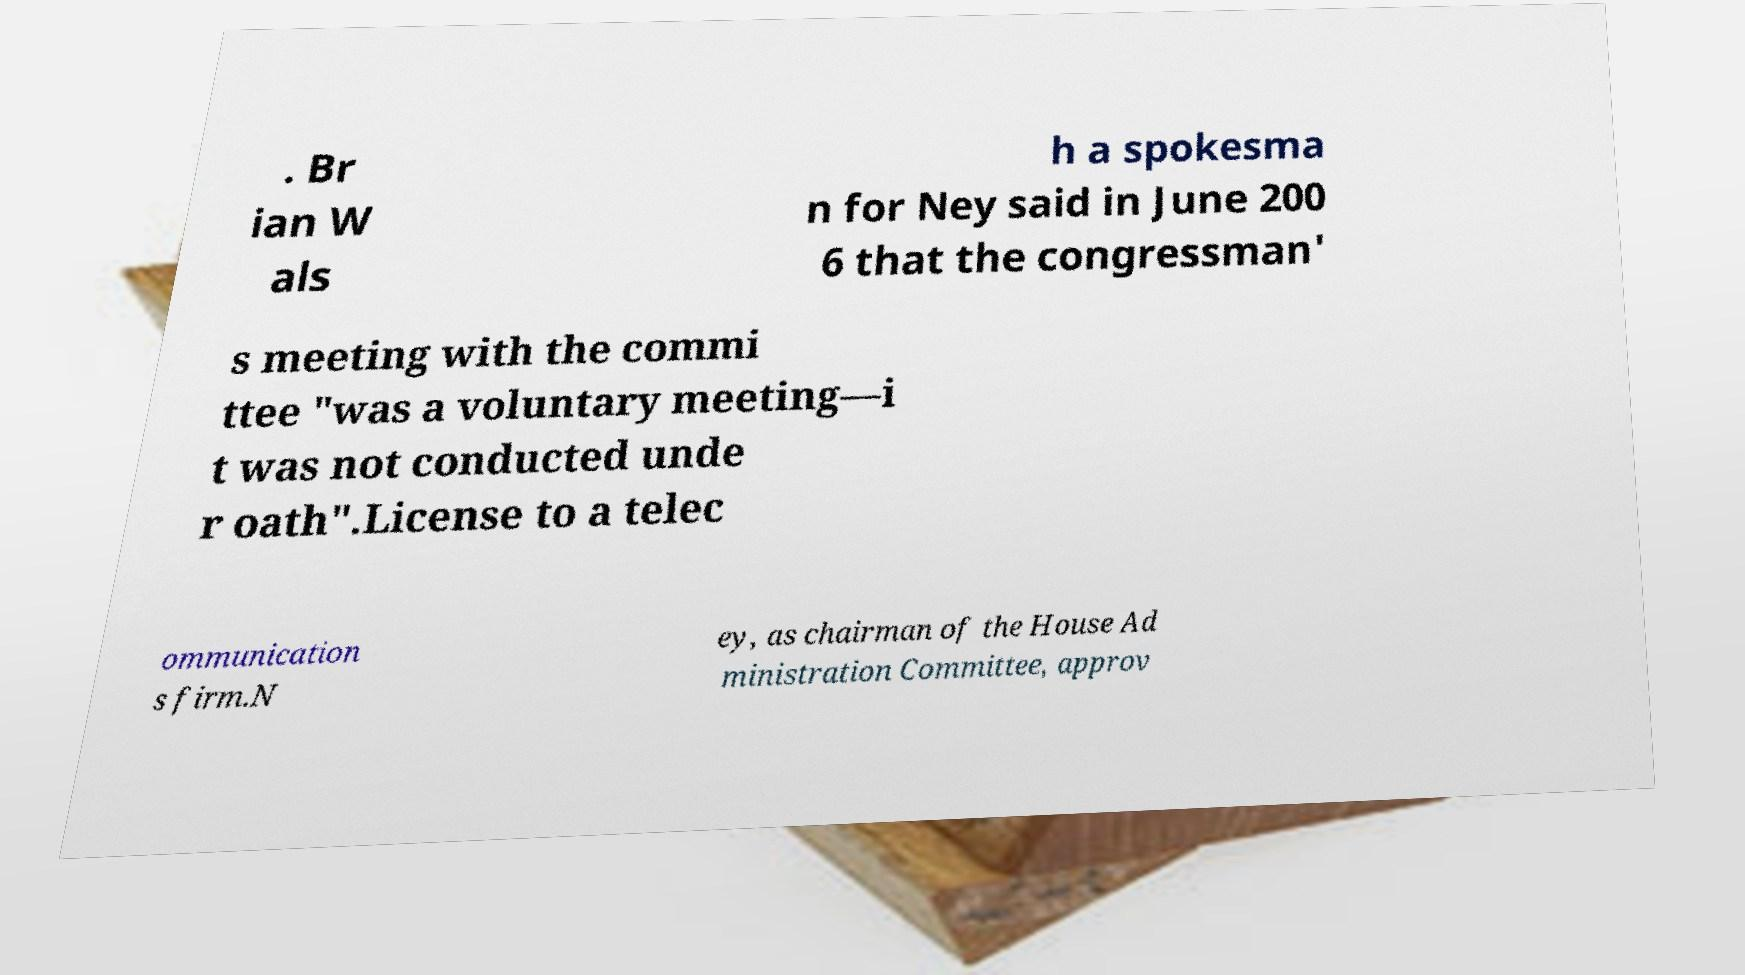There's text embedded in this image that I need extracted. Can you transcribe it verbatim? . Br ian W als h a spokesma n for Ney said in June 200 6 that the congressman' s meeting with the commi ttee "was a voluntary meeting—i t was not conducted unde r oath".License to a telec ommunication s firm.N ey, as chairman of the House Ad ministration Committee, approv 